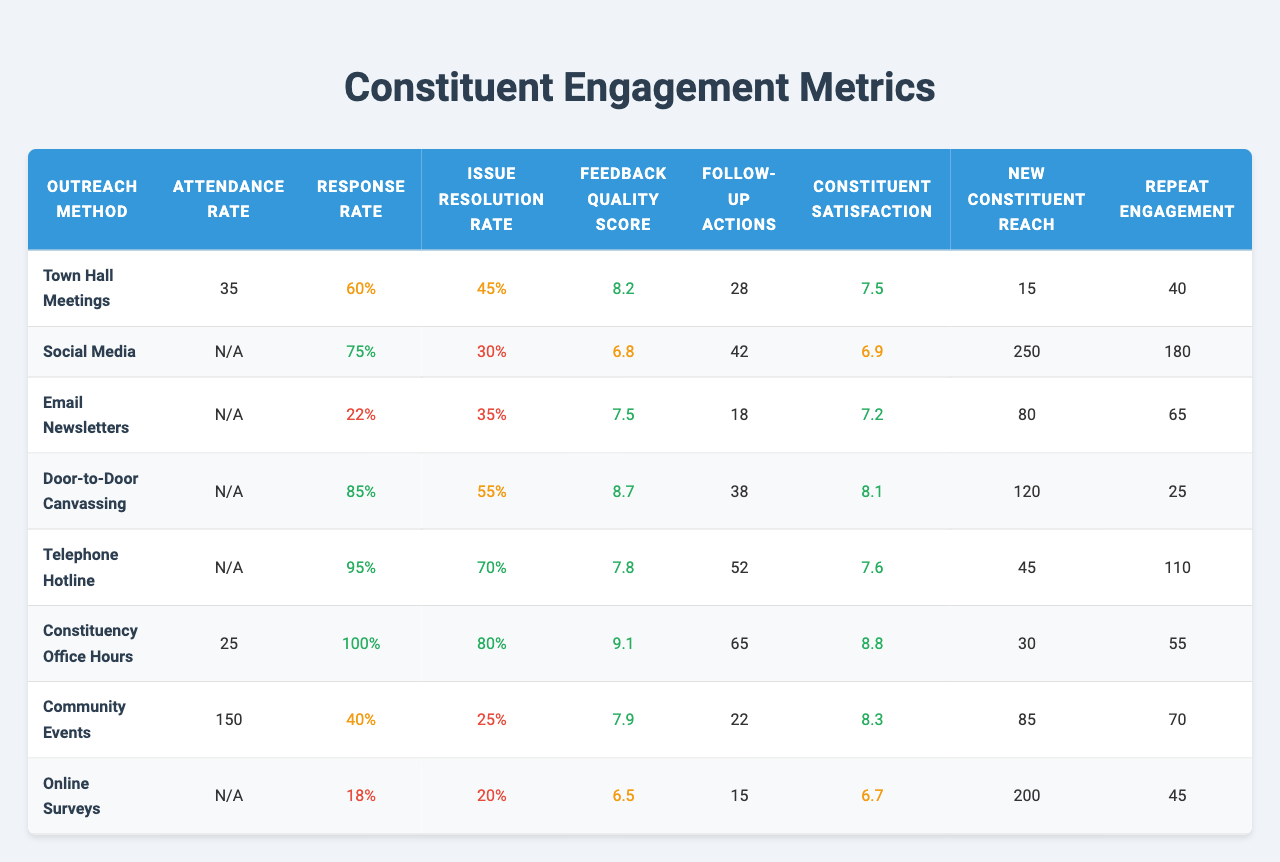What is the highest attendance rate among the outreach methods? The attendance rates are 35 for Town Hall Meetings, 25 for Constituency Office Hours, and 150 for Community Events. The highest is clearly 150 for Community Events.
Answer: 150 What is the response rate for the Telephone Hotline? The table shows a response rate of 95% for the Telephone Hotline.
Answer: 95% Which outreach method has the lowest feedback quality score? By inspecting the table, the lowest feedback quality score is 6.5 for Online Surveys compared to other methods.
Answer: 6.5 What is the issue resolution rate for Social Media? The issue resolution rate for Social Media is listed as 30%.
Answer: 30% Which outreach method has the highest new constituent reach? Social Media has the highest new constituent reach at 250, as noted in the outreach methods data.
Answer: 250 Is the constituent satisfaction for Door-to-Door Canvassing greater than that for Email Newsletters? The satisfaction rate for Door-to-Door Canvassing is 8.1, while for Email Newsletters it is 7.2. Since 8.1 is greater than 7.2, the answer is yes.
Answer: Yes What is the average issue resolution rate across all outreach methods? Adding the issue resolution rates (45, 30, 35, 55, 70, 80, 25, 20) gives a total of 390. Dividing by the number of methods (8) results in an average of 48.75.
Answer: 48.75 Which outreach method has the highest follow-up actions, and how many are there? Looking at the table, Telephone Hotline has the highest follow-up actions at 52.
Answer: 52 What is the difference in constituency satisfaction between Town Hall Meetings and Constituency Office Hours? Town Hall Meetings have a satisfaction of 7.5, and Constituency Office Hours has 8.8. The difference is 8.8 - 7.5 = 1.3.
Answer: 1.3 Is the feedback quality score for Community Events below 7? The feedback quality score for Community Events is 7.9 which is above 7. Therefore, this statement is false.
Answer: No 